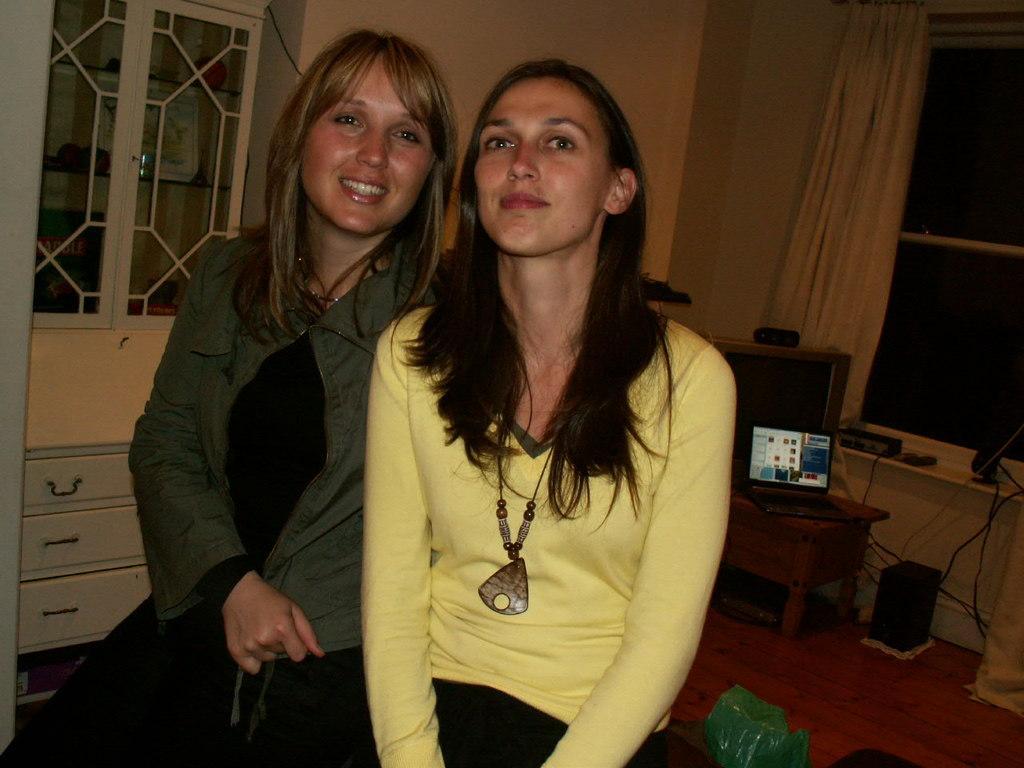In one or two sentences, can you explain what this image depicts? In this picture we can see two woman sitting and smiling and in background we can see wall, curtains, frame, wires, speakers, monitor, window, racks. 